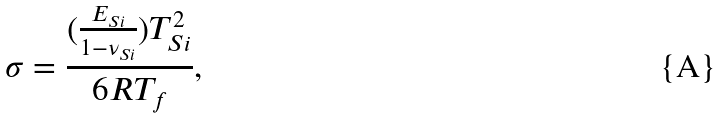<formula> <loc_0><loc_0><loc_500><loc_500>\sigma = \frac { ( \frac { E _ { S i } } { 1 - \nu _ { S i } } ) T _ { S i } ^ { 2 } } { 6 R T _ { f } } ,</formula> 